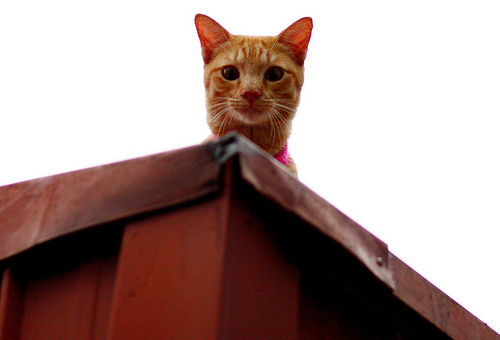<image>
Can you confirm if the cat is on the roof? Yes. Looking at the image, I can see the cat is positioned on top of the roof, with the roof providing support. Is the house in front of the sky? Yes. The house is positioned in front of the sky, appearing closer to the camera viewpoint. 